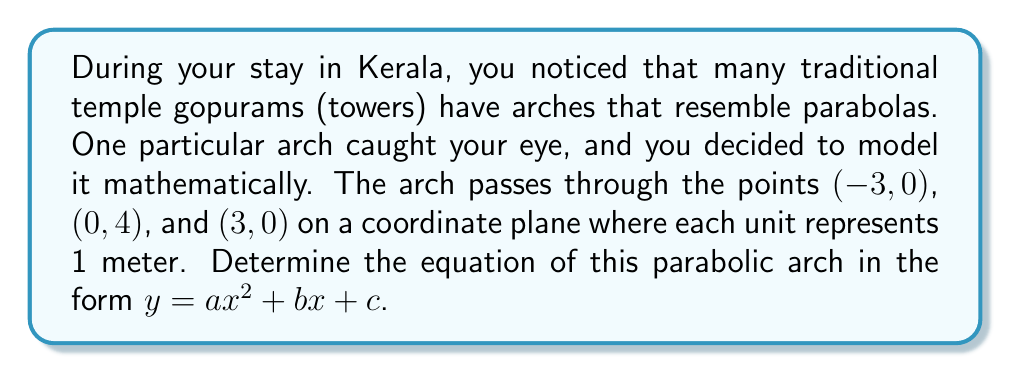Teach me how to tackle this problem. Let's approach this step-by-step:

1) The general form of a parabola is $y = ax^2 + bx + c$, where $a$, $b$, and $c$ are constants and $a \neq 0$.

2) We know three points that the parabola passes through:
   (-3, 0), (0, 4), and (3, 0)

3) Let's substitute these points into the general equation:

   For (-3, 0): $0 = a(-3)^2 + b(-3) + c = 9a - 3b + c$
   For (0, 4):  $4 = a(0)^2 + b(0) + c = c$
   For (3, 0):  $0 = a(3)^2 + b(3) + c = 9a + 3b + c$

4) From the second equation, we know that $c = 4$.

5) Subtracting the third equation from the first:
   $(9a - 3b + c) - (9a + 3b + c) = 0 - 0$
   $-6b = 0$
   $b = 0$

6) Now, let's substitute $b = 0$ and $c = 4$ into either the first or third equation:
   $0 = 9a + 4$
   $9a = -4$
   $a = -\frac{4}{9}$

7) Therefore, the equation of the parabola is:

   $y = -\frac{4}{9}x^2 + 4$

[asy]
import graph;
size(200);
real f(real x) {return -4/9*x^2 + 4;}
draw(graph(f,-3,3));
dot((-3,0));
dot((0,4));
dot((3,0));
xaxis(Arrows);
yaxis(Arrows);
label("x",(4,0),E);
label("y",(0,4.5),N);
[/asy]
Answer: $y = -\frac{4}{9}x^2 + 4$ 